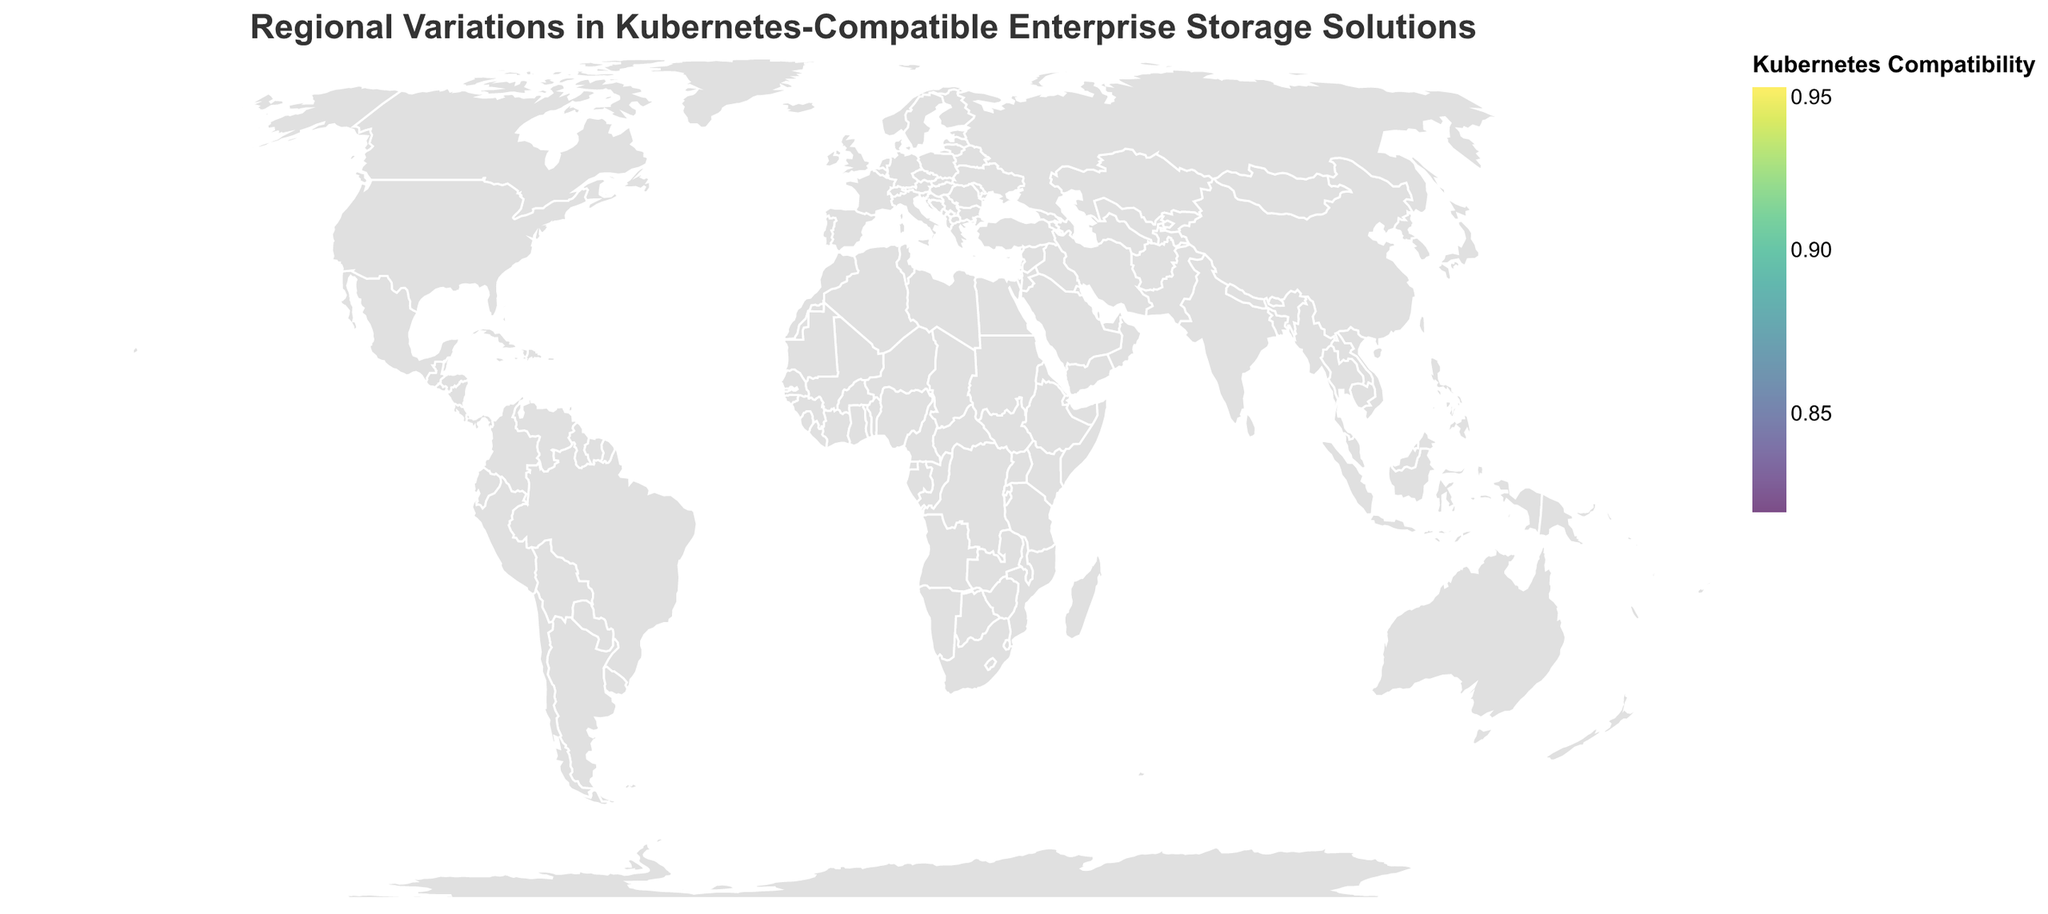What's the title of the figure? The title of the figure is typically found at the top of the visual representation. In this case, it reads "Regional Variations in Kubernetes-Compatible Enterprise Storage Solutions," as specified in the code.
Answer: Regional Variations in Kubernetes-Compatible Enterprise Storage Solutions How many regions are displayed in the figure? By counting the number of data points provided in the code, we can determine that there are 12 regions represented in the figure.
Answer: 12 Which region has the highest Kubernetes Compatibility? Observing the color legend and the distribution, the region plotted with the brightest color corresponding to the highest compatibility value is North America, which has a Kubernetes Compatibility of 0.95.
Answer: North America Which storage solution has the lowest adoption rate, and in which region is it used? By examining the sizes of the circles (which represent the adoption rates) and comparing them, the smallest circle represents Africa with "MayaData" as the storage solution, having an adoption rate of 0.35.
Answer: MayaData in Africa What's the range of adoption rates among the regions? The adoption rates range from the minimum value in Africa (0.35) to the maximum value in North America (0.72). Therefore, the range is 0.72 - 0.35 = 0.37.
Answer: 0.37 Which region has the largest circle, and what does it represent? The region with the largest circle is North America, representing the highest adoption rate of 0.72 for the "Rook" storage solution.
Answer: North America Which regions are represented with an adoption rate above 60%? By checking the adoption rates presented in the tooltips or noting the larger circles, the regions with adoption rates above 60% are North America (0.72), Western Europe (0.68), Nordic Countries (0.70), East Asia (0.62), and Europe (0.65).
Answer: North America, Western Europe, Nordic Countries, East Asia, Europe Compare the adoption rate of 'Portworx' in South America with 'Pure Storage' in Southeast Asia. Which is higher, and by how much? The adoption rate for Portworx in South America is 0.45 and for Pure Storage in Southeast Asia is 0.50. The difference is 0.50 - 0.45 = 0.05, so Pure Storage has a higher adoption rate by 0.05.
Answer: Pure Storage by 0.05 Which region has the highest adoption rate for a storage solution that is less than 90% compatible with Kubernetes? Checking the compatibility scores along with the adoption rates, the highest adoption rate with less than 90% compatibility is Europe with OpenEBS, having an adoption rate of 0.65 and a compatibility of 0.88.
Answer: Europe 